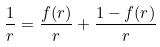Convert formula to latex. <formula><loc_0><loc_0><loc_500><loc_500>\frac { 1 } { r } = \frac { f ( r ) } { r } + \frac { 1 - f ( r ) } { r }</formula> 